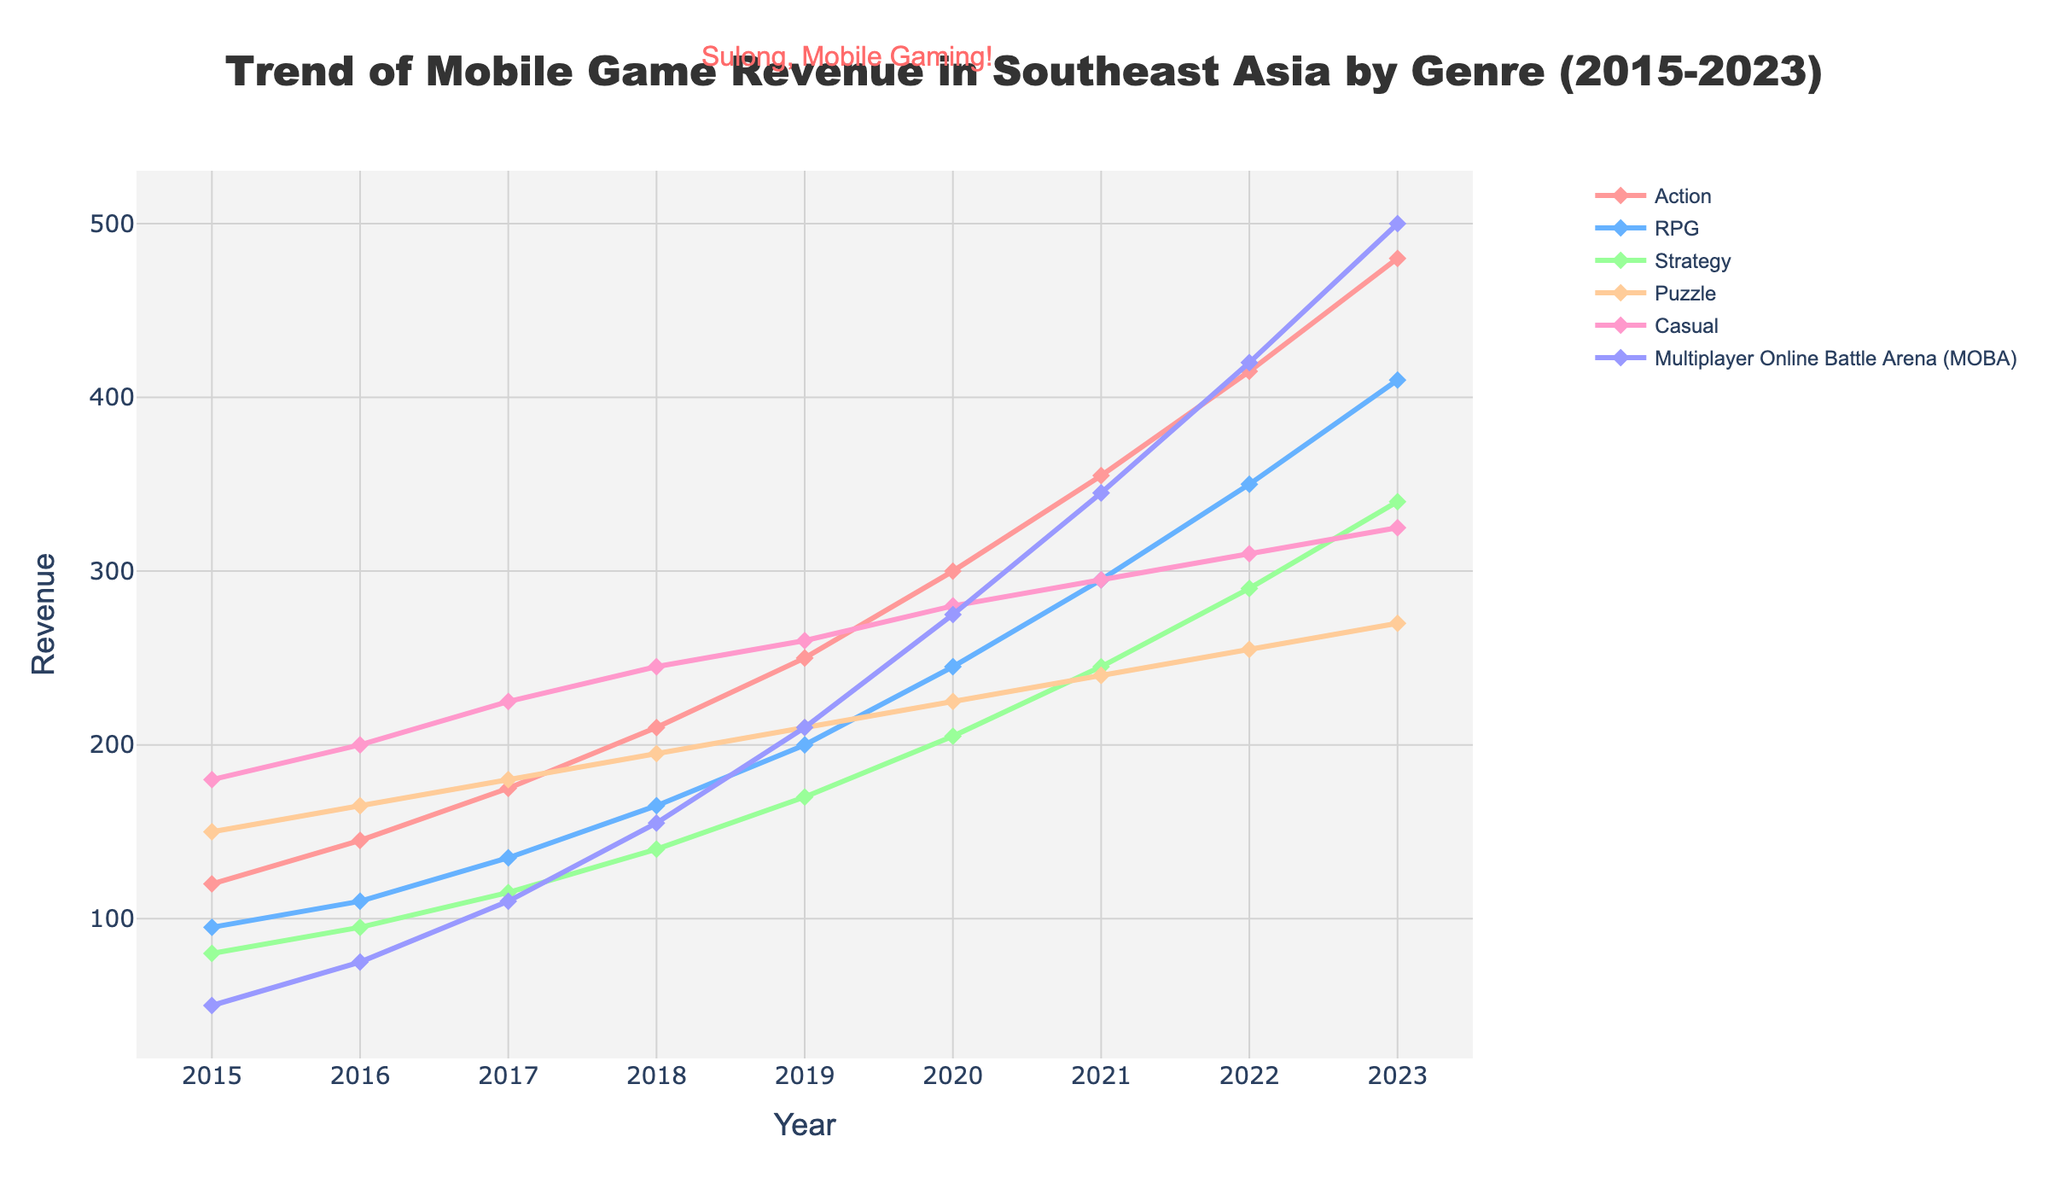What is the genre with the highest revenue in 2023? In 2023, the genre with the highest revenue is the one with the tallest line on the chart. By visually inspecting the lines, the MOBA genre has the highest revenue.
Answer: Multiplayer Online Battle Arena (MOBA) Which genre had the most significant increase in revenue from 2015 to 2023? To find the genre with the most significant increase, compare the difference between the 2023 and 2015 values for each genre. The increase for MOBA is 500 - 50 = 450, and for other genres: Action (480-120 = 360); RPG (410-95 = 315); Strategy (340-80 = 260); Puzzle (270-150 = 120); Casual (325-180 = 145). The most significant increase is for MOBA.
Answer: Multiplayer Online Battle Arena (MOBA) Which genre had the smallest growth in revenue between 2015 and 2023? To identify the genre with the smallest growth, calculate the difference between the 2023 and 2015 values for each genre. The growth for MOBA is (500 - 50 = 450); Action (480 - 120 = 360); RPG (410 - 95 = 315); Strategy (340 - 80 = 260); Puzzle (270 - 150 = 120); Casual (325 - 180 = 145). The smallest growth is in the Puzzle genre.
Answer: Puzzle By how much did the revenue for RPG games increase from 2016 to 2019? To determine the increase, subtract the 2016 value from the 2019 value for RPG games. The revenue in 2016 was 110 and in 2019 it was 200. Hence, the increase is 200 - 110 = 90.
Answer: 90 From which year did the MOBA genre overtake the Puzzle genre in revenue? Look for the first year where the MOBA line surpasses the Puzzle line by moving left to right. From the graph, MOBA revenue overtakes Puzzle revenue in 2019.
Answer: 2019 Which two genres had the closest revenue in 2021? To find the closest revenues, compare the values for all genres in 2021: Action (355), RPG (295), Strategy (245), Puzzle (240), Casual (295), MOBA (345). The RPG and Casual genres both have 295, making their revenues the closest.
Answer: RPG and Casual What was the average revenue for the Casual genre between 2015 and 2023? To find the average, sum up the values for each year and divide by the number of years (9). The sum is 180 + 200 + 225 + 245 + 260 + 280 + 295 + 310 + 325 = 2420. Thus, the average revenue is 2420 / 9 ≈ 268.9.
Answer: 268.9 In what year did the Action genre first exceed 300 in revenue? Trace the Action genre line and note the first year its revenue surpasses 300. In the graph, this occurs in 2020 where its revenue is 300.
Answer: 2020 How much did the revenue for Strategy games change from 2017 to 2023? Calculate the difference between the 2023 and 2017 values for Strategy games. The revenue in 2017 was 115 and in 2023 it is 340. Hence, the change is 340 - 115 = 225.
Answer: 225 